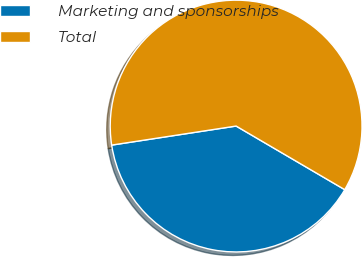<chart> <loc_0><loc_0><loc_500><loc_500><pie_chart><fcel>Marketing and sponsorships<fcel>Total<nl><fcel>39.15%<fcel>60.85%<nl></chart> 